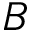Convert formula to latex. <formula><loc_0><loc_0><loc_500><loc_500>B</formula> 